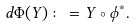Convert formula to latex. <formula><loc_0><loc_0><loc_500><loc_500>d \Phi ( Y ) \colon = Y \circ \phi ^ { * } .</formula> 